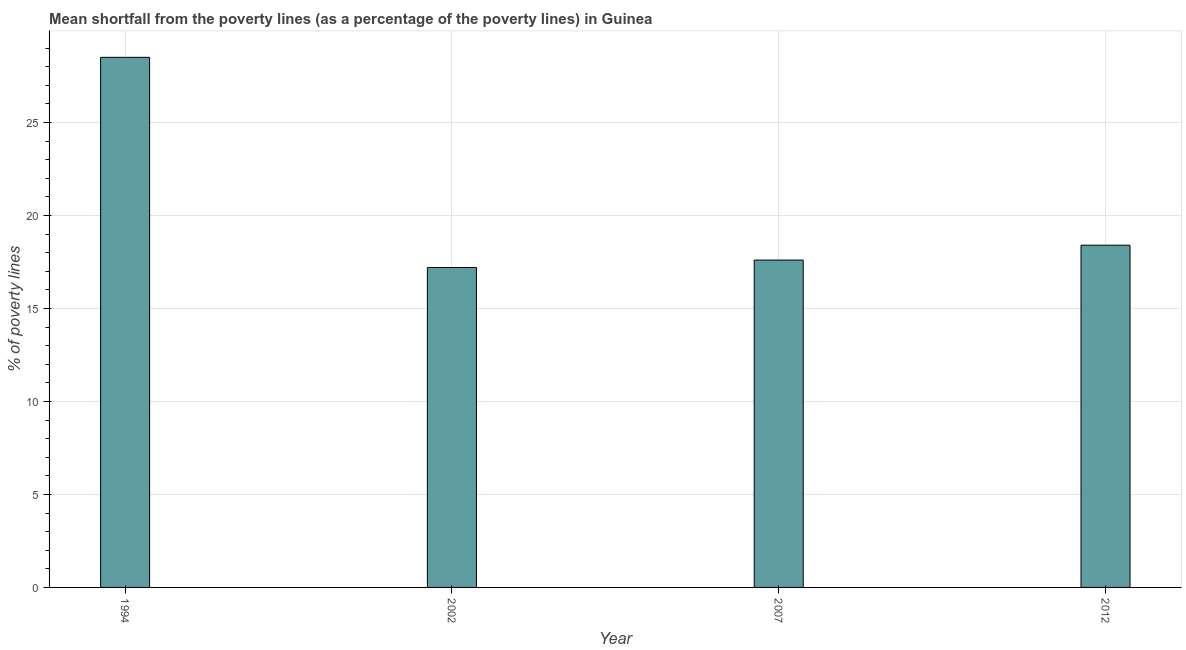Does the graph contain any zero values?
Your response must be concise. No. Does the graph contain grids?
Your response must be concise. Yes. What is the title of the graph?
Provide a succinct answer. Mean shortfall from the poverty lines (as a percentage of the poverty lines) in Guinea. What is the label or title of the Y-axis?
Your response must be concise. % of poverty lines. Across all years, what is the minimum poverty gap at national poverty lines?
Your response must be concise. 17.2. In which year was the poverty gap at national poverty lines minimum?
Provide a succinct answer. 2002. What is the sum of the poverty gap at national poverty lines?
Keep it short and to the point. 81.7. What is the average poverty gap at national poverty lines per year?
Your answer should be compact. 20.43. In how many years, is the poverty gap at national poverty lines greater than 22 %?
Offer a terse response. 1. Do a majority of the years between 2007 and 2012 (inclusive) have poverty gap at national poverty lines greater than 4 %?
Your answer should be compact. Yes. What is the ratio of the poverty gap at national poverty lines in 2002 to that in 2012?
Your answer should be very brief. 0.94. In how many years, is the poverty gap at national poverty lines greater than the average poverty gap at national poverty lines taken over all years?
Your answer should be compact. 1. How many bars are there?
Your response must be concise. 4. How many years are there in the graph?
Provide a succinct answer. 4. What is the % of poverty lines in 1994?
Your answer should be compact. 28.5. What is the % of poverty lines of 2002?
Keep it short and to the point. 17.2. What is the difference between the % of poverty lines in 1994 and 2002?
Your answer should be compact. 11.3. What is the difference between the % of poverty lines in 2002 and 2012?
Your answer should be very brief. -1.2. What is the ratio of the % of poverty lines in 1994 to that in 2002?
Give a very brief answer. 1.66. What is the ratio of the % of poverty lines in 1994 to that in 2007?
Offer a very short reply. 1.62. What is the ratio of the % of poverty lines in 1994 to that in 2012?
Your answer should be compact. 1.55. What is the ratio of the % of poverty lines in 2002 to that in 2012?
Your answer should be compact. 0.94. What is the ratio of the % of poverty lines in 2007 to that in 2012?
Your response must be concise. 0.96. 